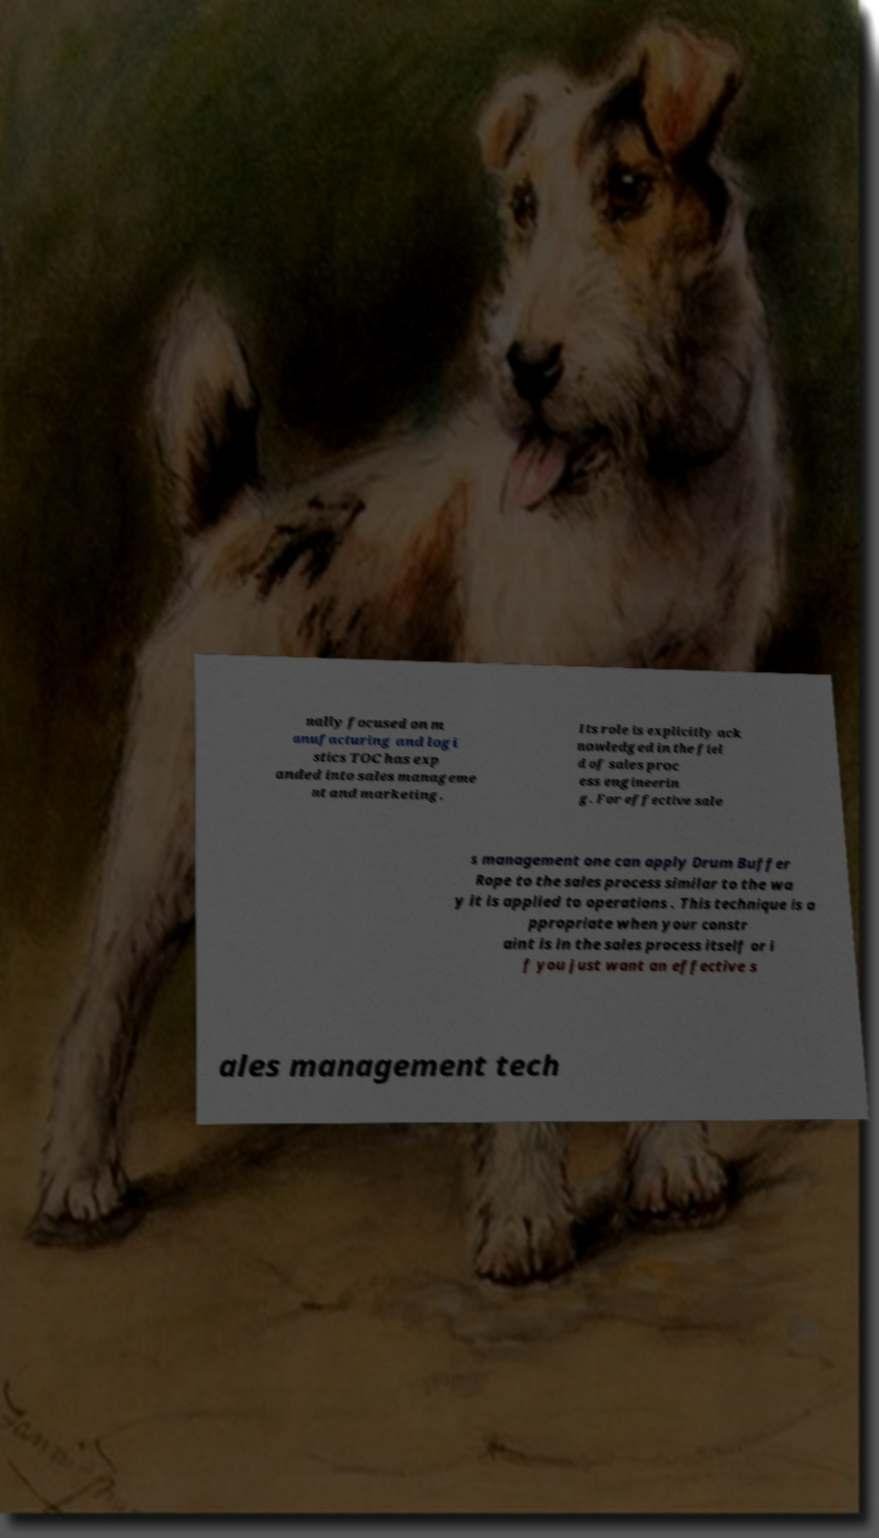Can you read and provide the text displayed in the image?This photo seems to have some interesting text. Can you extract and type it out for me? nally focused on m anufacturing and logi stics TOC has exp anded into sales manageme nt and marketing. Its role is explicitly ack nowledged in the fiel d of sales proc ess engineerin g. For effective sale s management one can apply Drum Buffer Rope to the sales process similar to the wa y it is applied to operations . This technique is a ppropriate when your constr aint is in the sales process itself or i f you just want an effective s ales management tech 